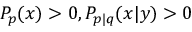<formula> <loc_0><loc_0><loc_500><loc_500>P _ { p } ( x ) > 0 , P _ { p | q } ( x | y ) > 0</formula> 